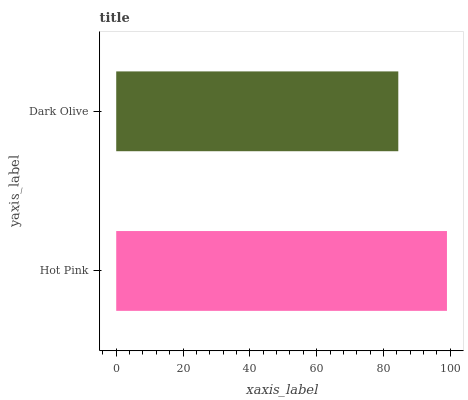Is Dark Olive the minimum?
Answer yes or no. Yes. Is Hot Pink the maximum?
Answer yes or no. Yes. Is Dark Olive the maximum?
Answer yes or no. No. Is Hot Pink greater than Dark Olive?
Answer yes or no. Yes. Is Dark Olive less than Hot Pink?
Answer yes or no. Yes. Is Dark Olive greater than Hot Pink?
Answer yes or no. No. Is Hot Pink less than Dark Olive?
Answer yes or no. No. Is Hot Pink the high median?
Answer yes or no. Yes. Is Dark Olive the low median?
Answer yes or no. Yes. Is Dark Olive the high median?
Answer yes or no. No. Is Hot Pink the low median?
Answer yes or no. No. 